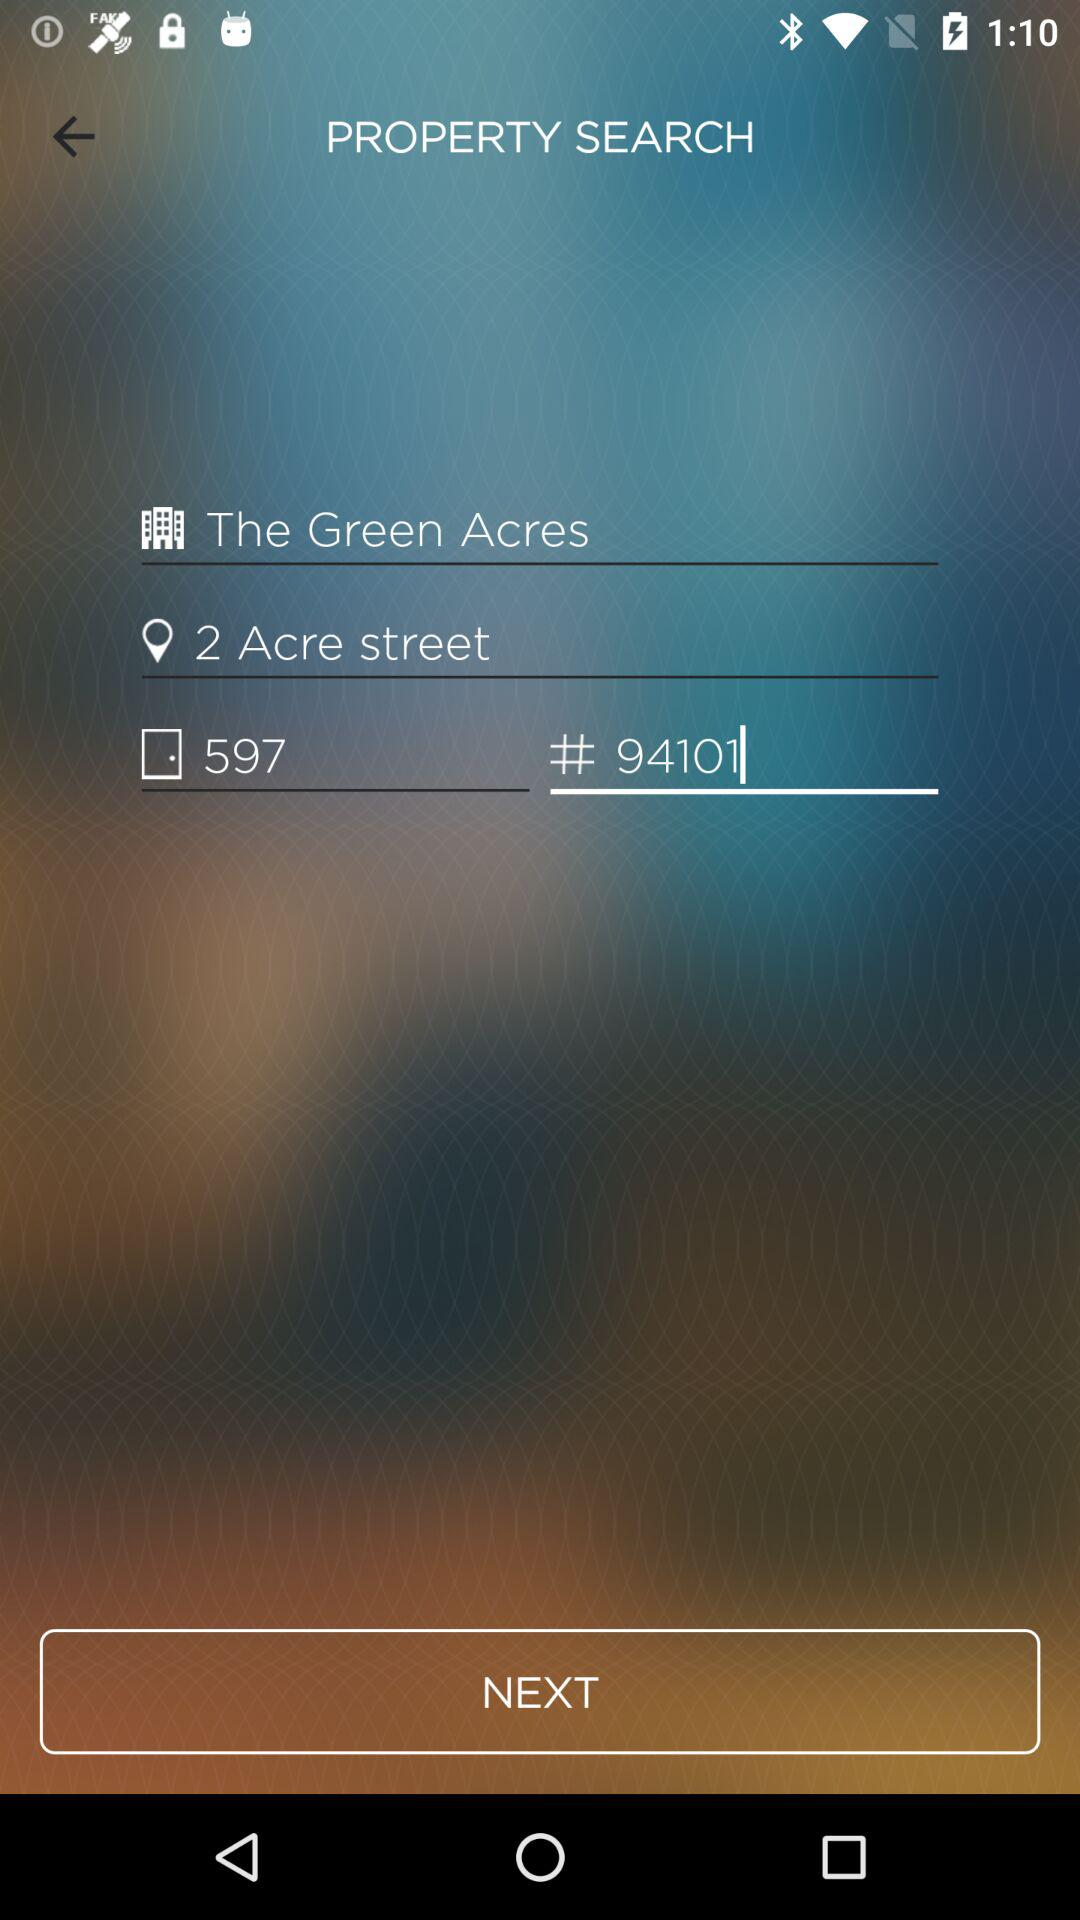What is the address of the property? The address is 597, 2 Acre Street, 94101. 